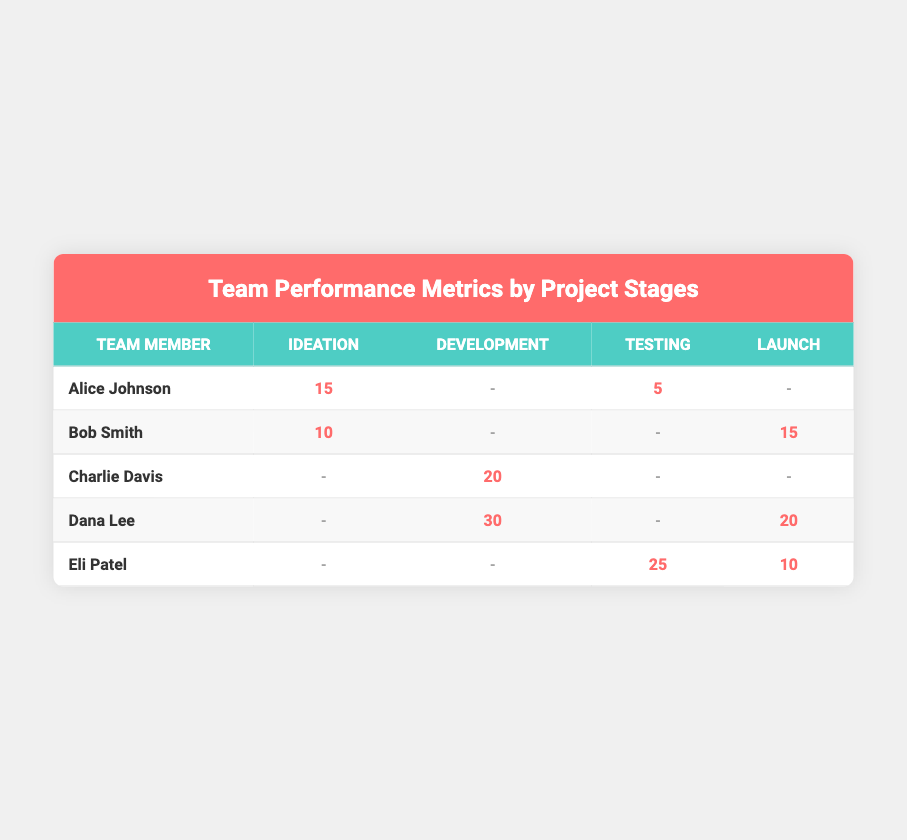What is the total contribution of Alice Johnson across all project stages? In the table, Alice Johnson contributed 15 in Ideation and 5 in Testing. There are no contributions in Development and Launch. Thus, the total contribution is 15 + 5 = 20.
Answer: 20 Who has the highest contribution in the Development stage? Looking at the Development column, Dana Lee has a contribution of 30, while Charlie Davis has a contribution of 20. Therefore, Dana Lee has the highest contribution in this stage.
Answer: Dana Lee Did Eli Patel contribute to the Launch stage? In the Launch column, Eli Patel has a contribution of 10. Therefore, the answer is yes.
Answer: Yes What is the average contribution of the team members in the Testing stage? The contributions in the Testing stage are 25 (Eli Patel) + 5 (Alice Johnson) = 30. There are 2 contributors in this stage, so the average is 30/2 = 15.
Answer: 15 Which team member contributed the least overall? The total contributions for each member are: Alice Johnson (20), Bob Smith (25), Charlie Davis (20), Dana Lee (50), and Eli Patel (35). Bob Smith has the lowest total contribution, with 25.
Answer: Bob Smith What is the sum of contributions from all team members in the Launch stage? The contributions in the Launch stage are 15 (Bob Smith) + 20 (Dana Lee) + 10 (Eli Patel) = 45.
Answer: 45 Did anyone contribute in the Ideation stage other than Alice Johnson? Looking at the Ideation column, the only contributions are from Alice Johnson (15) and Bob Smith (10). Therefore, the answer is yes.
Answer: Yes What is the difference in contributions between Dana Lee and Bob Smith in the Launch stage? Dana Lee contributed 20 and Bob Smith contributed 15 in the Launch stage. Thus, the difference is 20 - 15 = 5.
Answer: 5 Who contributed to the Testing stage without contributing to any other stages? In the Testing column, the contributions are 25 (Eli Patel) and 5 (Alice Johnson). However, Alice Johnson has contributions in Ideation. Therefore, Eli Patel is the only one who contributed solely in the Testing stage.
Answer: Eli Patel 